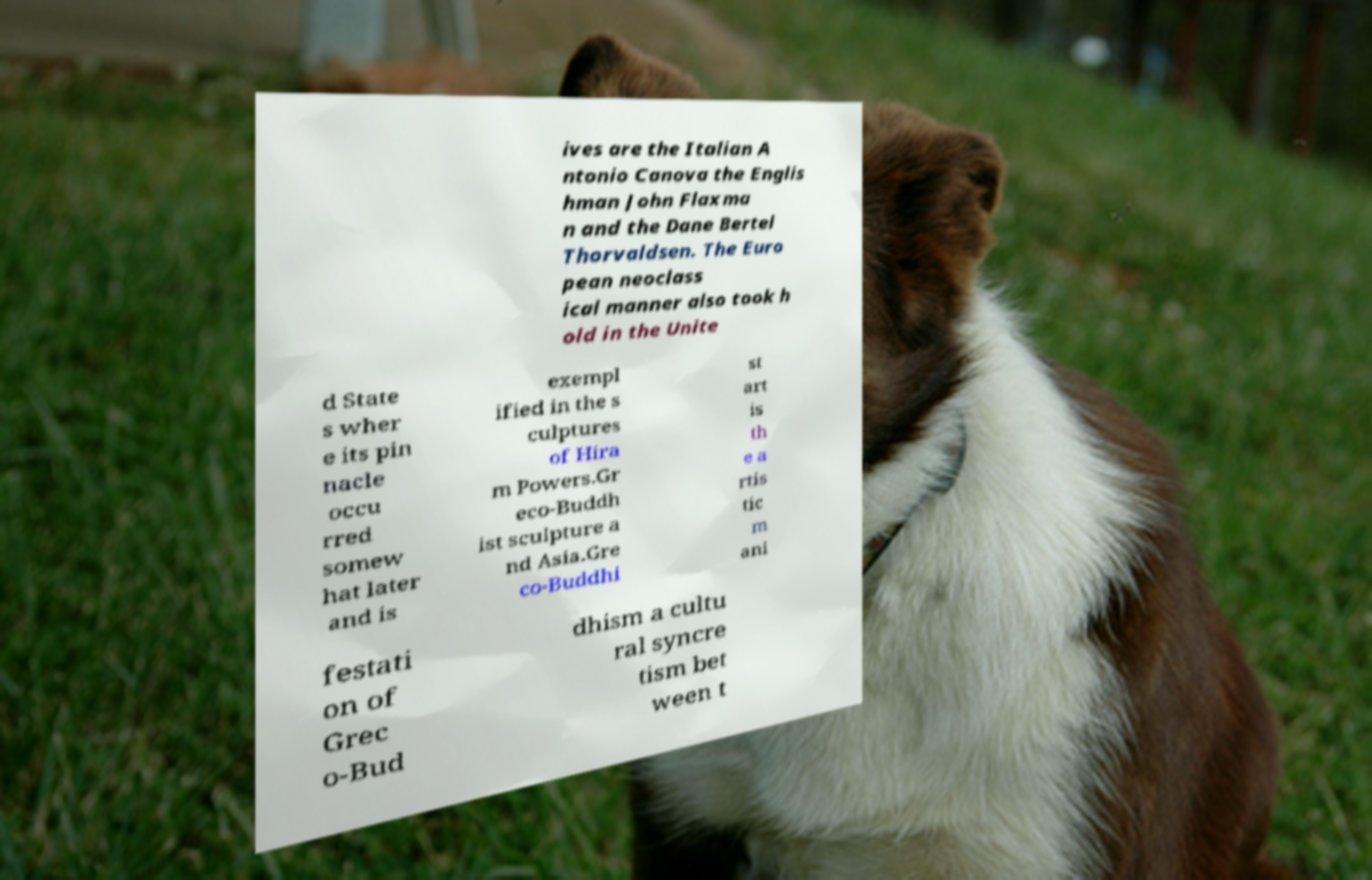Can you read and provide the text displayed in the image?This photo seems to have some interesting text. Can you extract and type it out for me? ives are the Italian A ntonio Canova the Englis hman John Flaxma n and the Dane Bertel Thorvaldsen. The Euro pean neoclass ical manner also took h old in the Unite d State s wher e its pin nacle occu rred somew hat later and is exempl ified in the s culptures of Hira m Powers.Gr eco-Buddh ist sculpture a nd Asia.Gre co-Buddhi st art is th e a rtis tic m ani festati on of Grec o-Bud dhism a cultu ral syncre tism bet ween t 